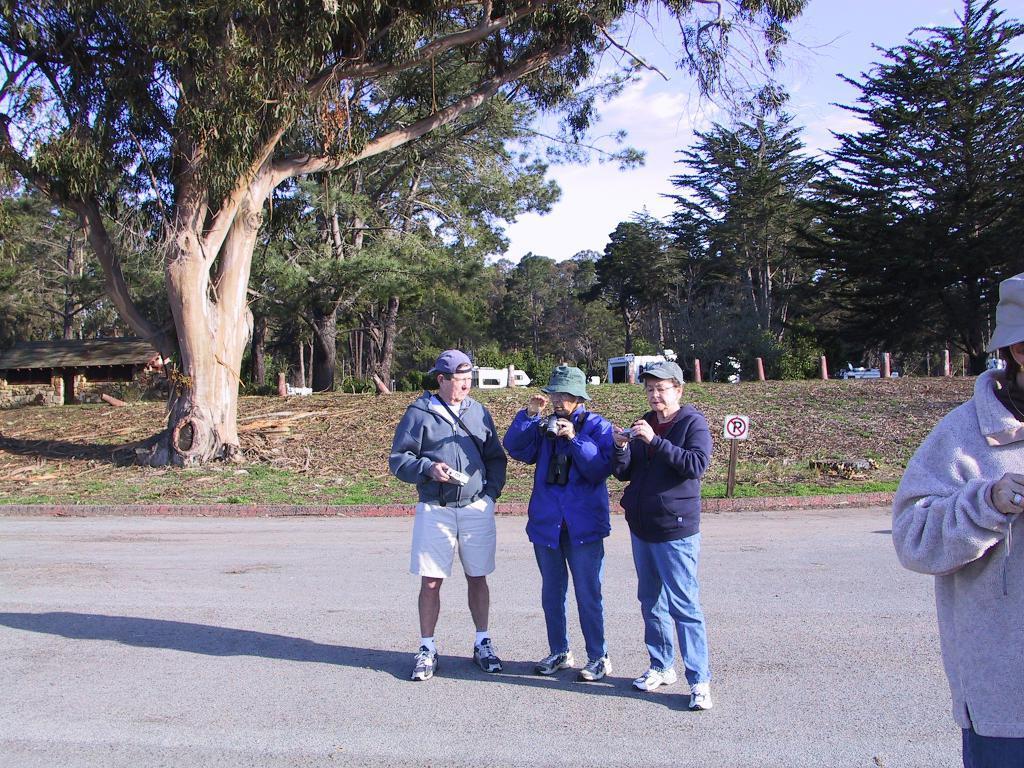Could you give a brief overview of what you see in this image? In this image we can see people standing on the road. In the background there are sky with clouds, trees, sheds, barrier poles, sign board and shredded leaves on the ground. 